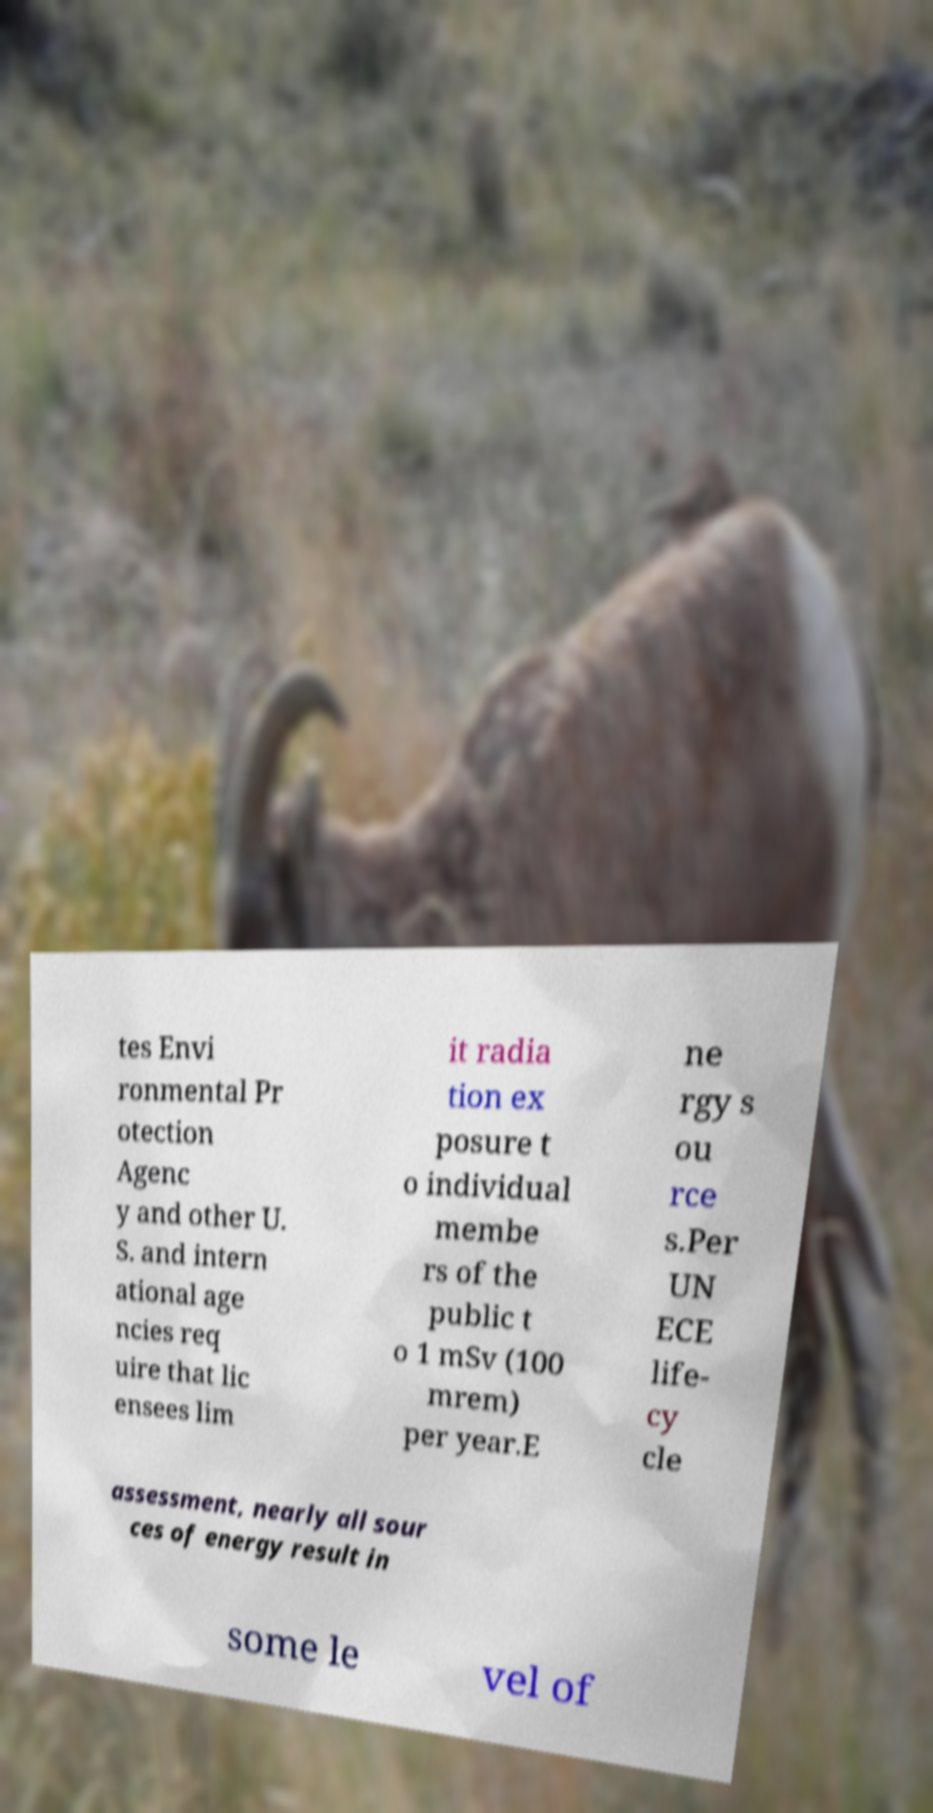Please identify and transcribe the text found in this image. tes Envi ronmental Pr otection Agenc y and other U. S. and intern ational age ncies req uire that lic ensees lim it radia tion ex posure t o individual membe rs of the public t o 1 mSv (100 mrem) per year.E ne rgy s ou rce s.Per UN ECE life- cy cle assessment, nearly all sour ces of energy result in some le vel of 